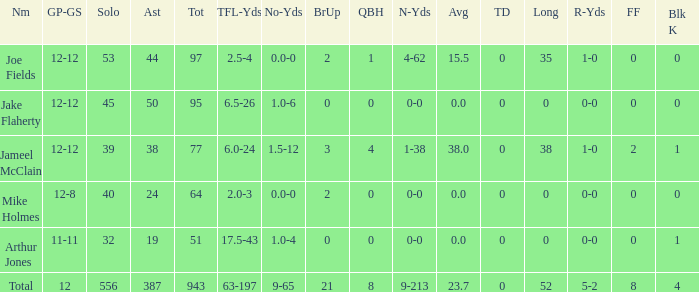What is the highest number of touchdowns achieved by a single player? 0.0. 